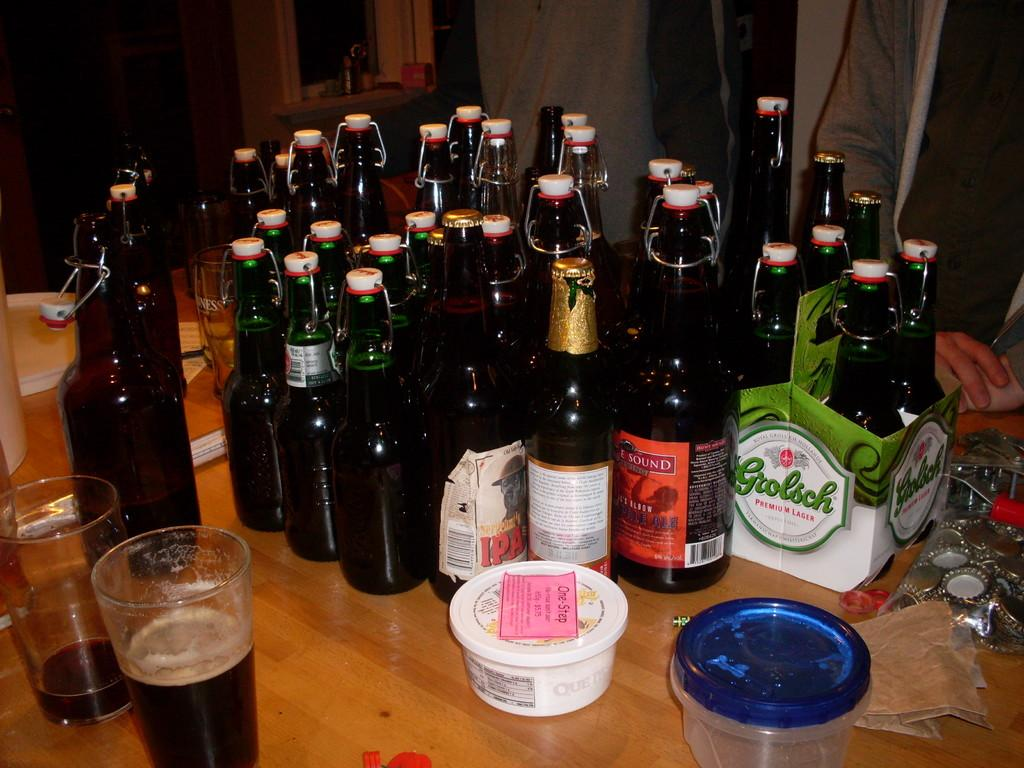<image>
Render a clear and concise summary of the photo. Many different beer bottles all crowded in a corner of the table, one of which is Grolsch Premium Lager as well as two beer glasses and One-Step container of queso. 